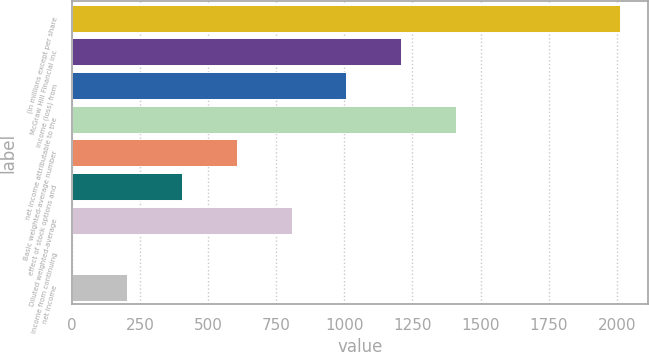Convert chart to OTSL. <chart><loc_0><loc_0><loc_500><loc_500><bar_chart><fcel>(in millions except per share<fcel>McGraw Hill Financial inc<fcel>income (loss) from<fcel>net income attributable to the<fcel>Basic weighted-average number<fcel>effect of stock options and<fcel>Diluted weighted-average<fcel>income from continuing<fcel>net income<nl><fcel>2013<fcel>1208.96<fcel>1007.96<fcel>1409.96<fcel>605.96<fcel>404.96<fcel>806.96<fcel>2.96<fcel>203.96<nl></chart> 